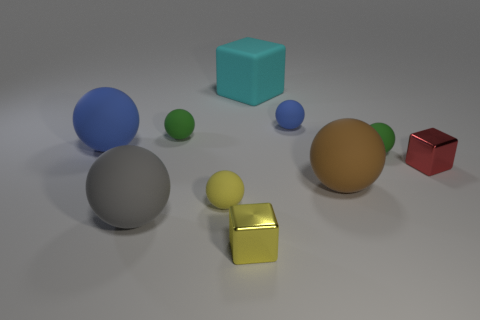What size is the gray matte thing that is the same shape as the brown rubber thing?
Offer a very short reply. Large. Does the gray object have the same shape as the large brown matte object?
Offer a very short reply. Yes. What color is the other small object that is made of the same material as the red thing?
Offer a very short reply. Yellow. What number of rubber things are gray spheres or tiny blue objects?
Your response must be concise. 2. What color is the large object to the right of the cyan object?
Your answer should be very brief. Brown. What is the shape of the brown matte object that is the same size as the gray ball?
Give a very brief answer. Sphere. What number of things are either tiny objects in front of the big gray matte sphere or large cyan rubber objects that are behind the large blue ball?
Keep it short and to the point. 2. What is the material of the yellow thing that is the same size as the yellow matte ball?
Give a very brief answer. Metal. What number of other things are the same material as the big brown sphere?
Your response must be concise. 7. Is the shape of the green object that is on the left side of the yellow block the same as the large gray object on the left side of the yellow sphere?
Your answer should be very brief. Yes. 